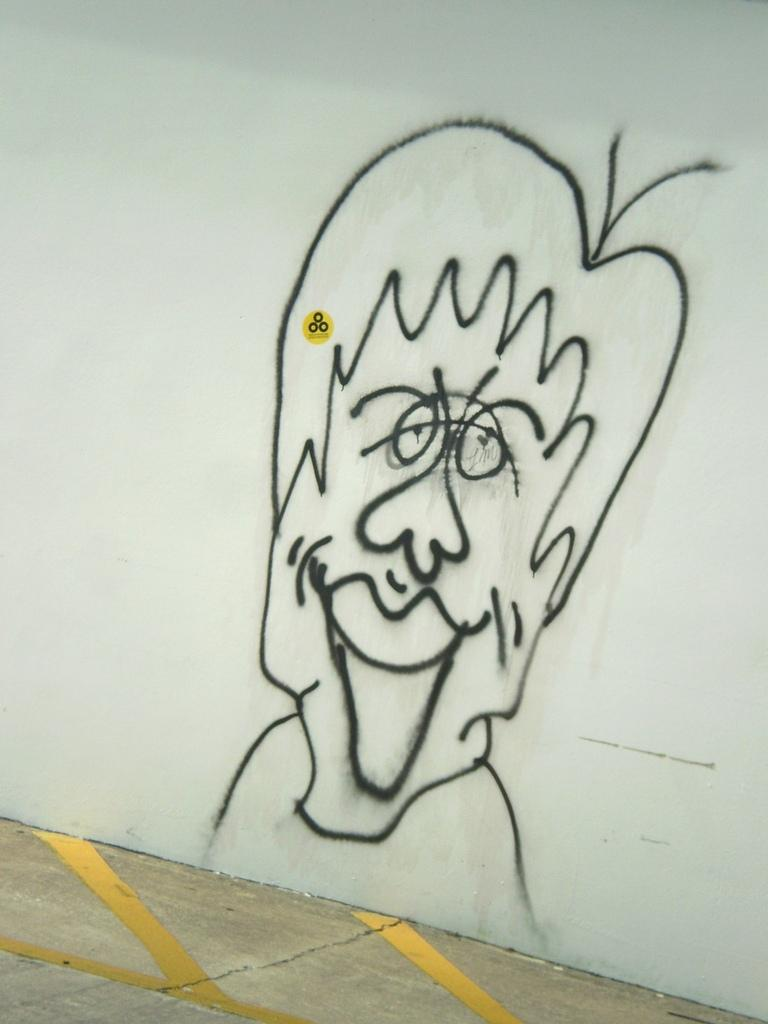What is depicted on the wall in the image? There is graffiti on a wall in the image. Where is the graffiti located on the wall? The graffiti is in the center of the image. What else can be seen in the image besides the graffiti? There is a floor visible at the bottom of the image. What type of blade can be seen in the aftermath of the graffiti incident in the image? There is no blade or any indication of an incident in the image; it only features graffiti on a wall and a visible floor. 